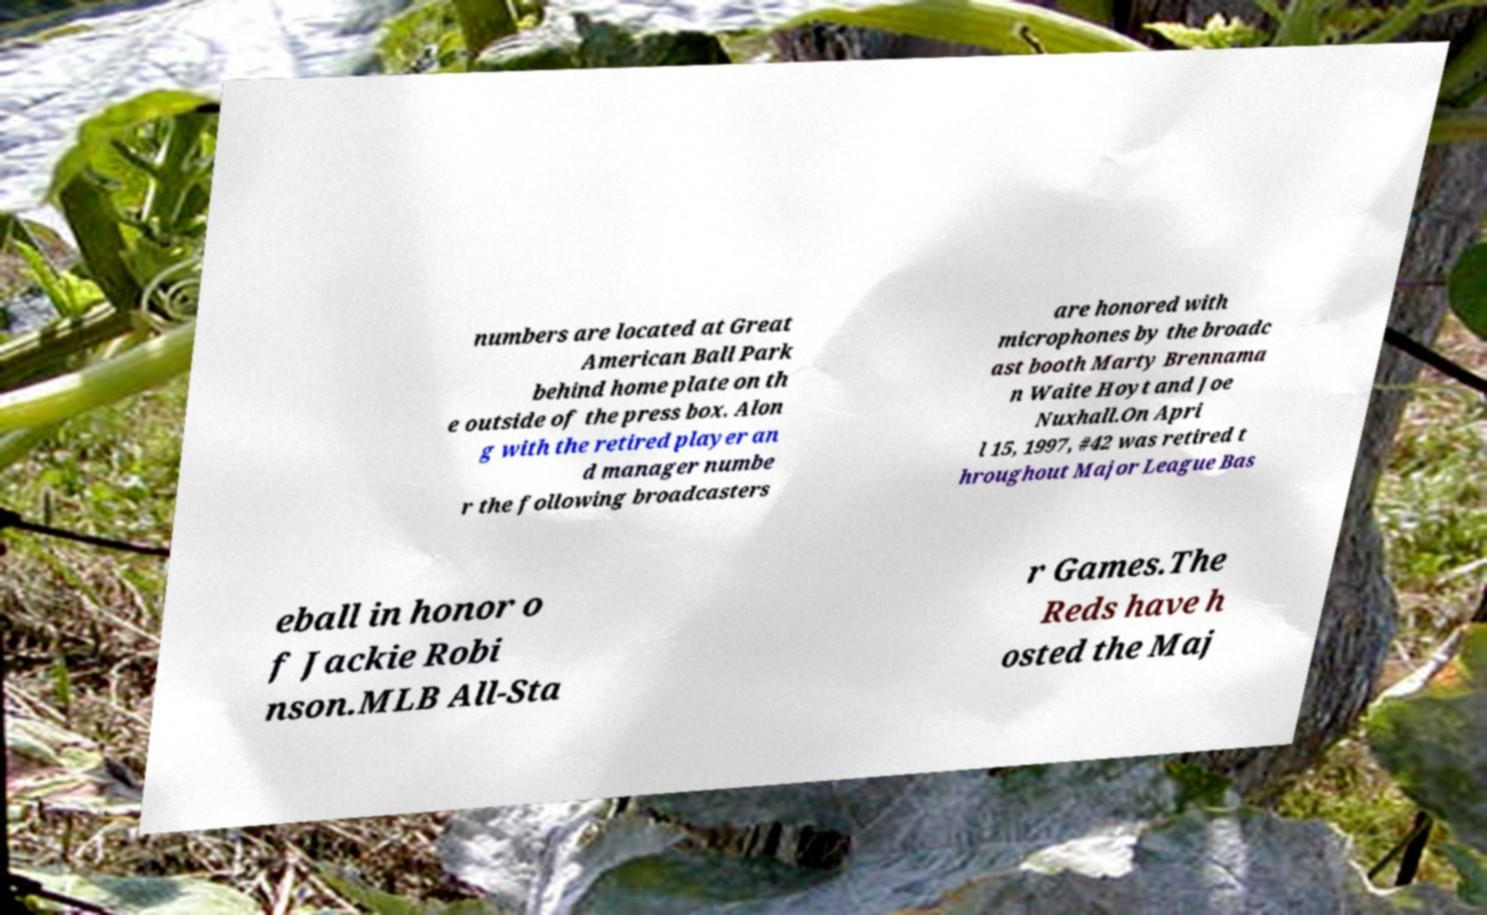Can you accurately transcribe the text from the provided image for me? numbers are located at Great American Ball Park behind home plate on th e outside of the press box. Alon g with the retired player an d manager numbe r the following broadcasters are honored with microphones by the broadc ast booth Marty Brennama n Waite Hoyt and Joe Nuxhall.On Apri l 15, 1997, #42 was retired t hroughout Major League Bas eball in honor o f Jackie Robi nson.MLB All-Sta r Games.The Reds have h osted the Maj 